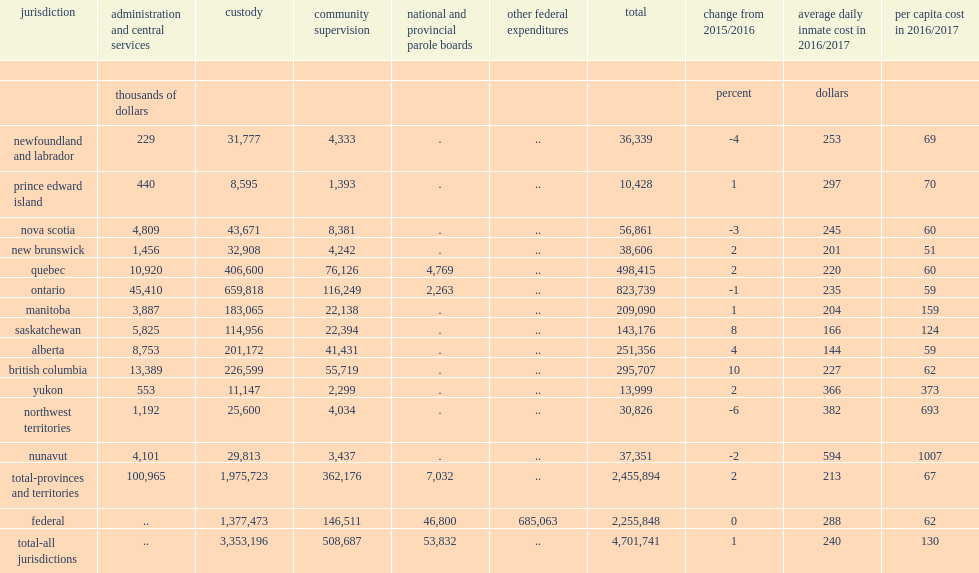In 2016/2017, what was the number of operating expenditures for adult correctional services in canada totaled? 4701741.0. In 2016/2017, how many percent did operating expenditures for adult correctional services in canada total increase from the previous year after adjusting for inflation? 1.0. 